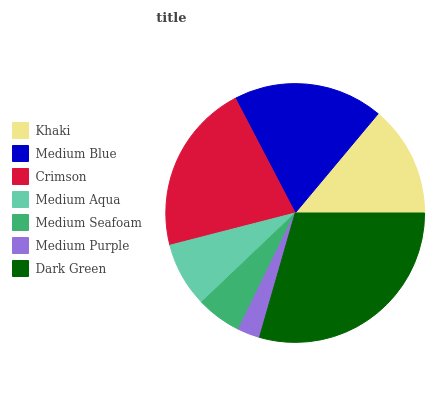Is Medium Purple the minimum?
Answer yes or no. Yes. Is Dark Green the maximum?
Answer yes or no. Yes. Is Medium Blue the minimum?
Answer yes or no. No. Is Medium Blue the maximum?
Answer yes or no. No. Is Medium Blue greater than Khaki?
Answer yes or no. Yes. Is Khaki less than Medium Blue?
Answer yes or no. Yes. Is Khaki greater than Medium Blue?
Answer yes or no. No. Is Medium Blue less than Khaki?
Answer yes or no. No. Is Khaki the high median?
Answer yes or no. Yes. Is Khaki the low median?
Answer yes or no. Yes. Is Medium Blue the high median?
Answer yes or no. No. Is Medium Seafoam the low median?
Answer yes or no. No. 